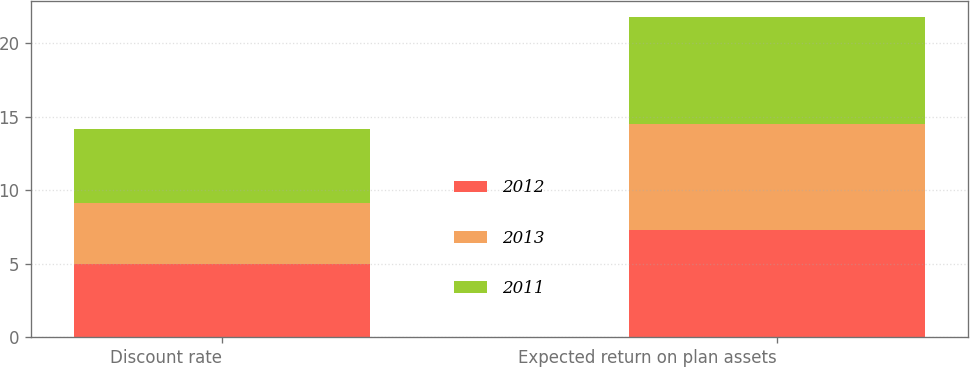<chart> <loc_0><loc_0><loc_500><loc_500><stacked_bar_chart><ecel><fcel>Discount rate<fcel>Expected return on plan assets<nl><fcel>2012<fcel>5<fcel>7.25<nl><fcel>2013<fcel>4.1<fcel>7.25<nl><fcel>2011<fcel>5.05<fcel>7.25<nl></chart> 